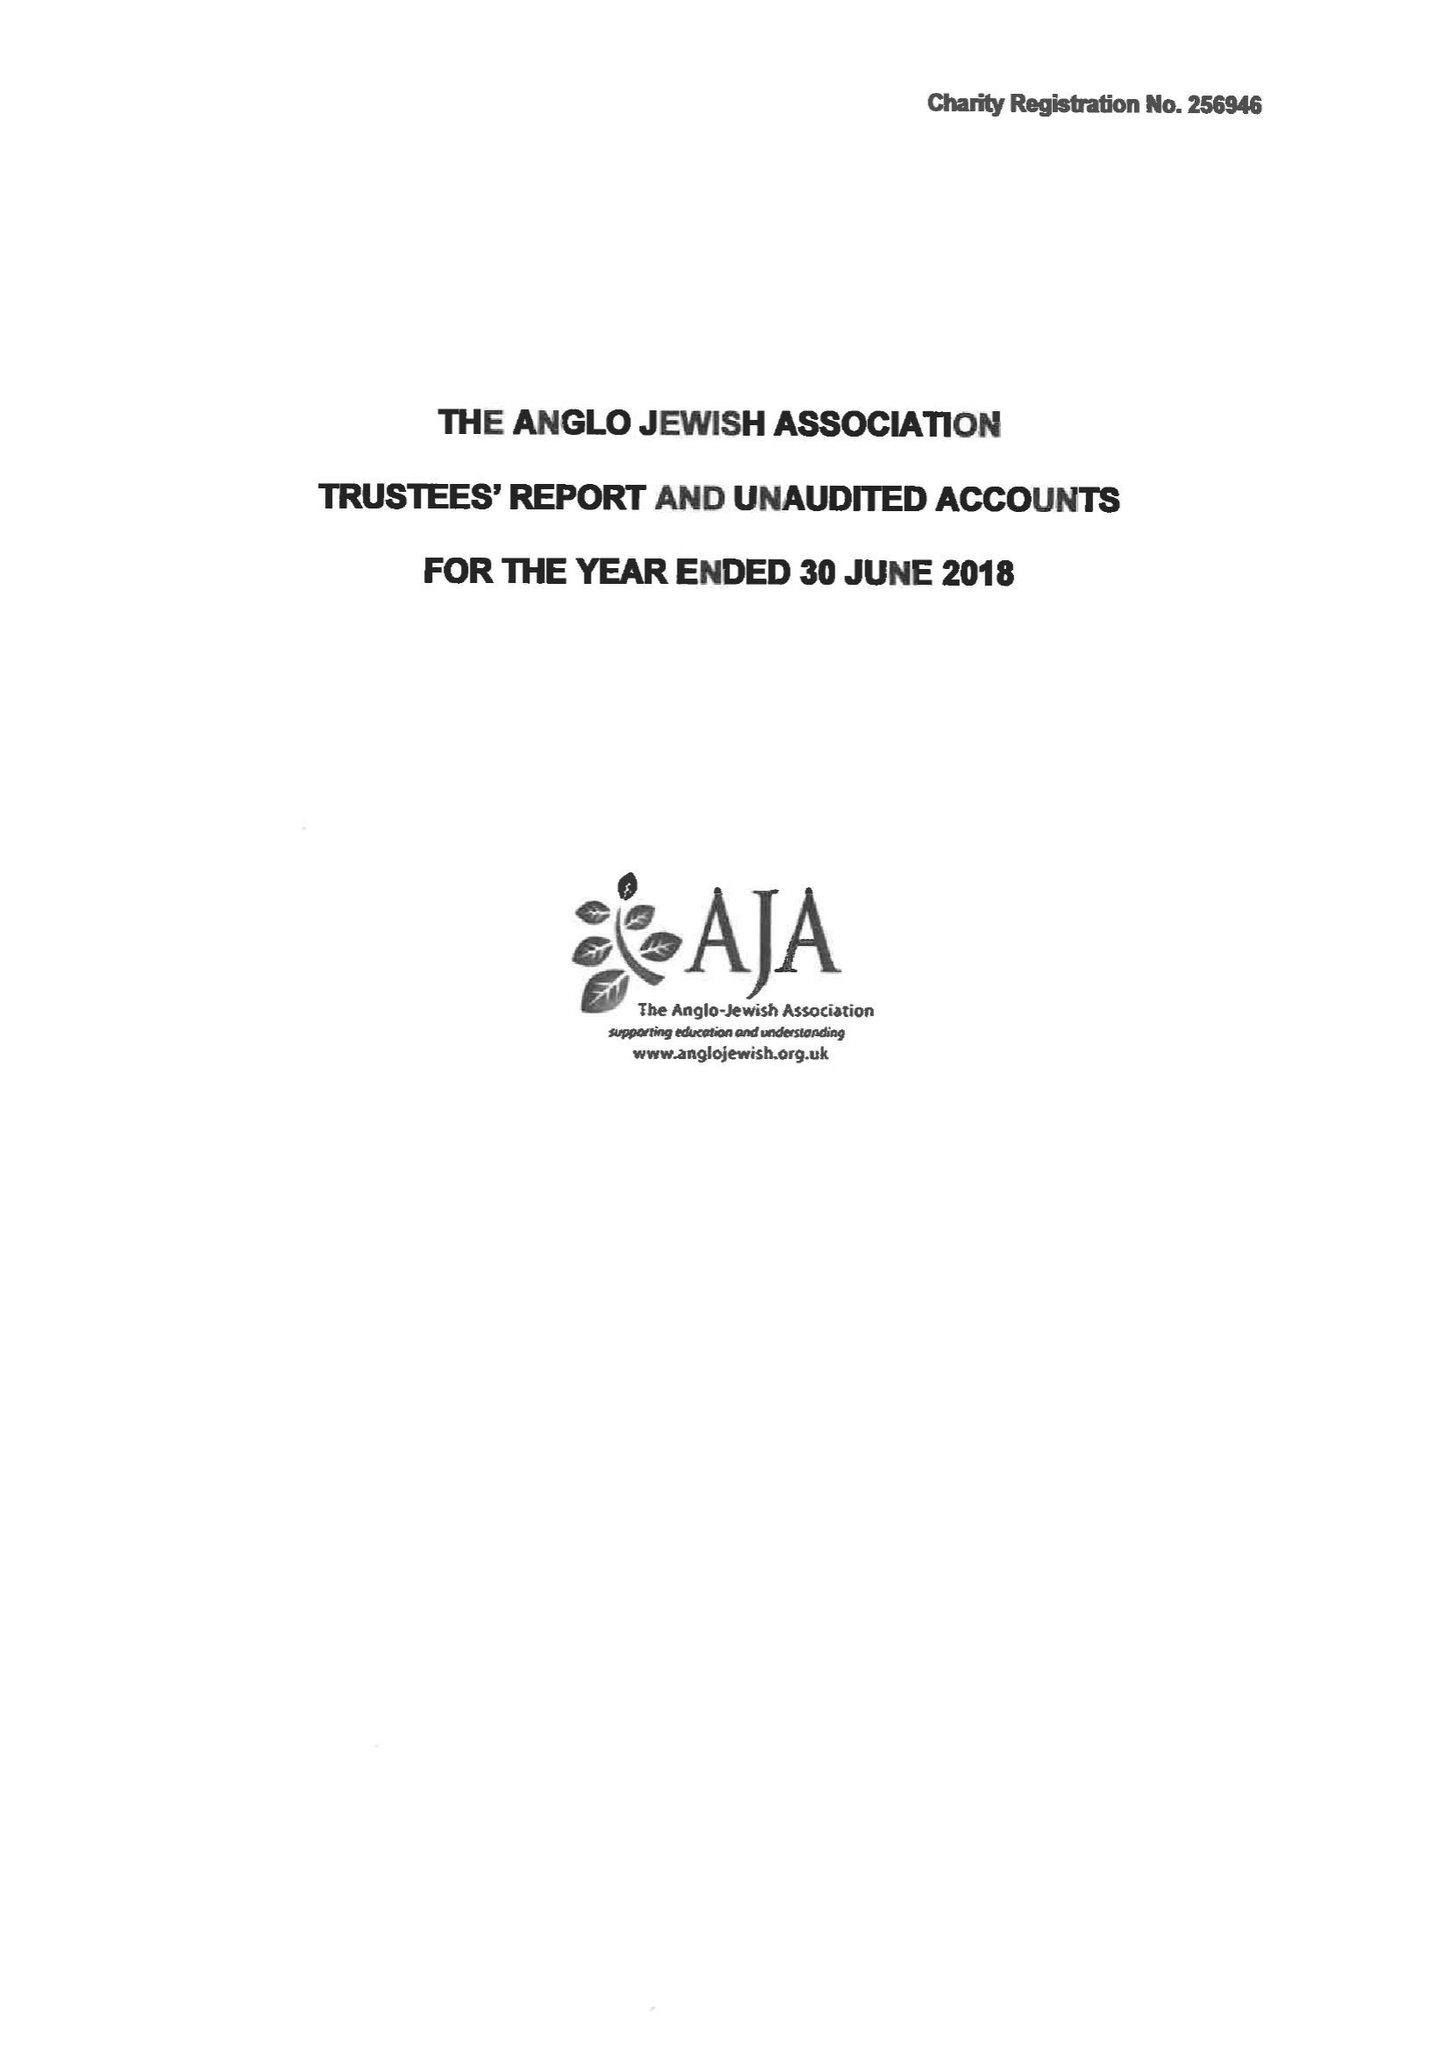What is the value for the charity_number?
Answer the question using a single word or phrase. 256946 